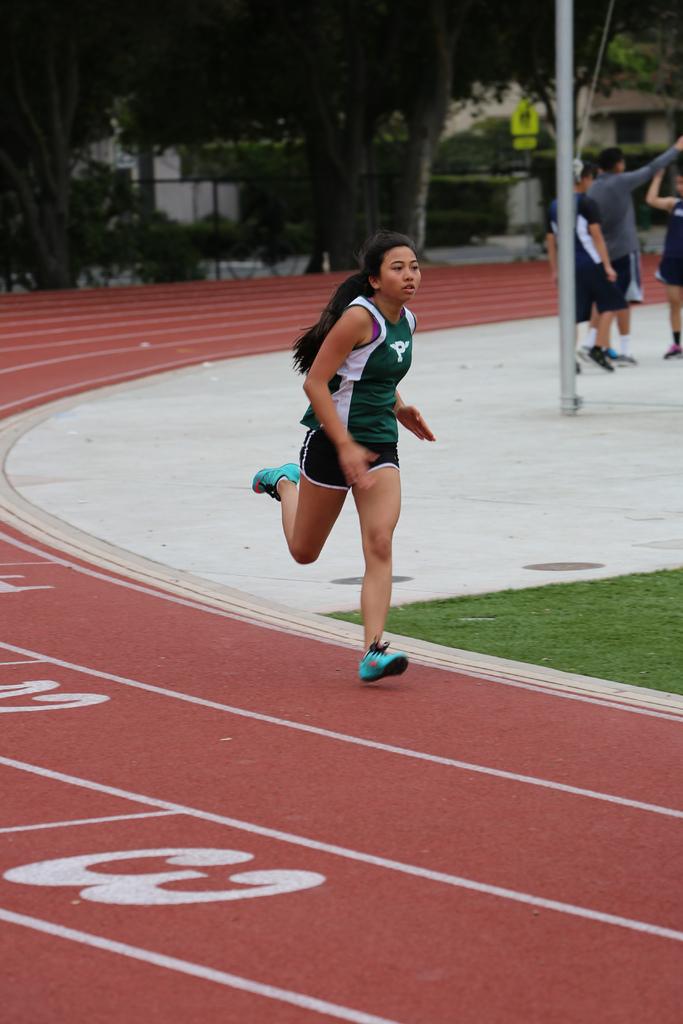What is the number of the left most lane?
Give a very brief answer. 3. What letter is on the runner's jersey?
Provide a short and direct response. P. 